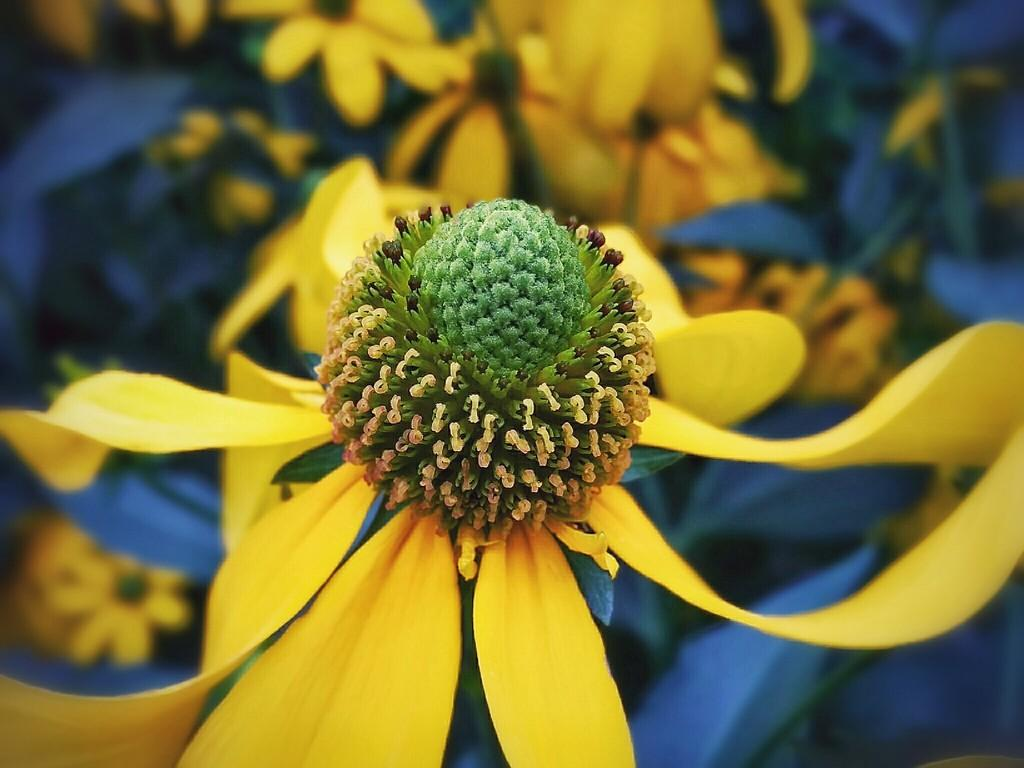What is the main subject of the picture? The main subject of the picture is a flower. Can you describe the appearance of the flower? The flower has yellow petals. What can be seen in the background of the picture? The backdrop of the picture is blurred, and there appear to be more flowers in the backdrop. What type of chalk is being used to draw on the petals of the flower in the image? There is no chalk or drawing activity present in the image; it features a flower with yellow petals. What kind of produce can be seen growing alongside the flower in the image? There is no produce visible in the image; it only shows a flower with yellow petals and a blurred background. 